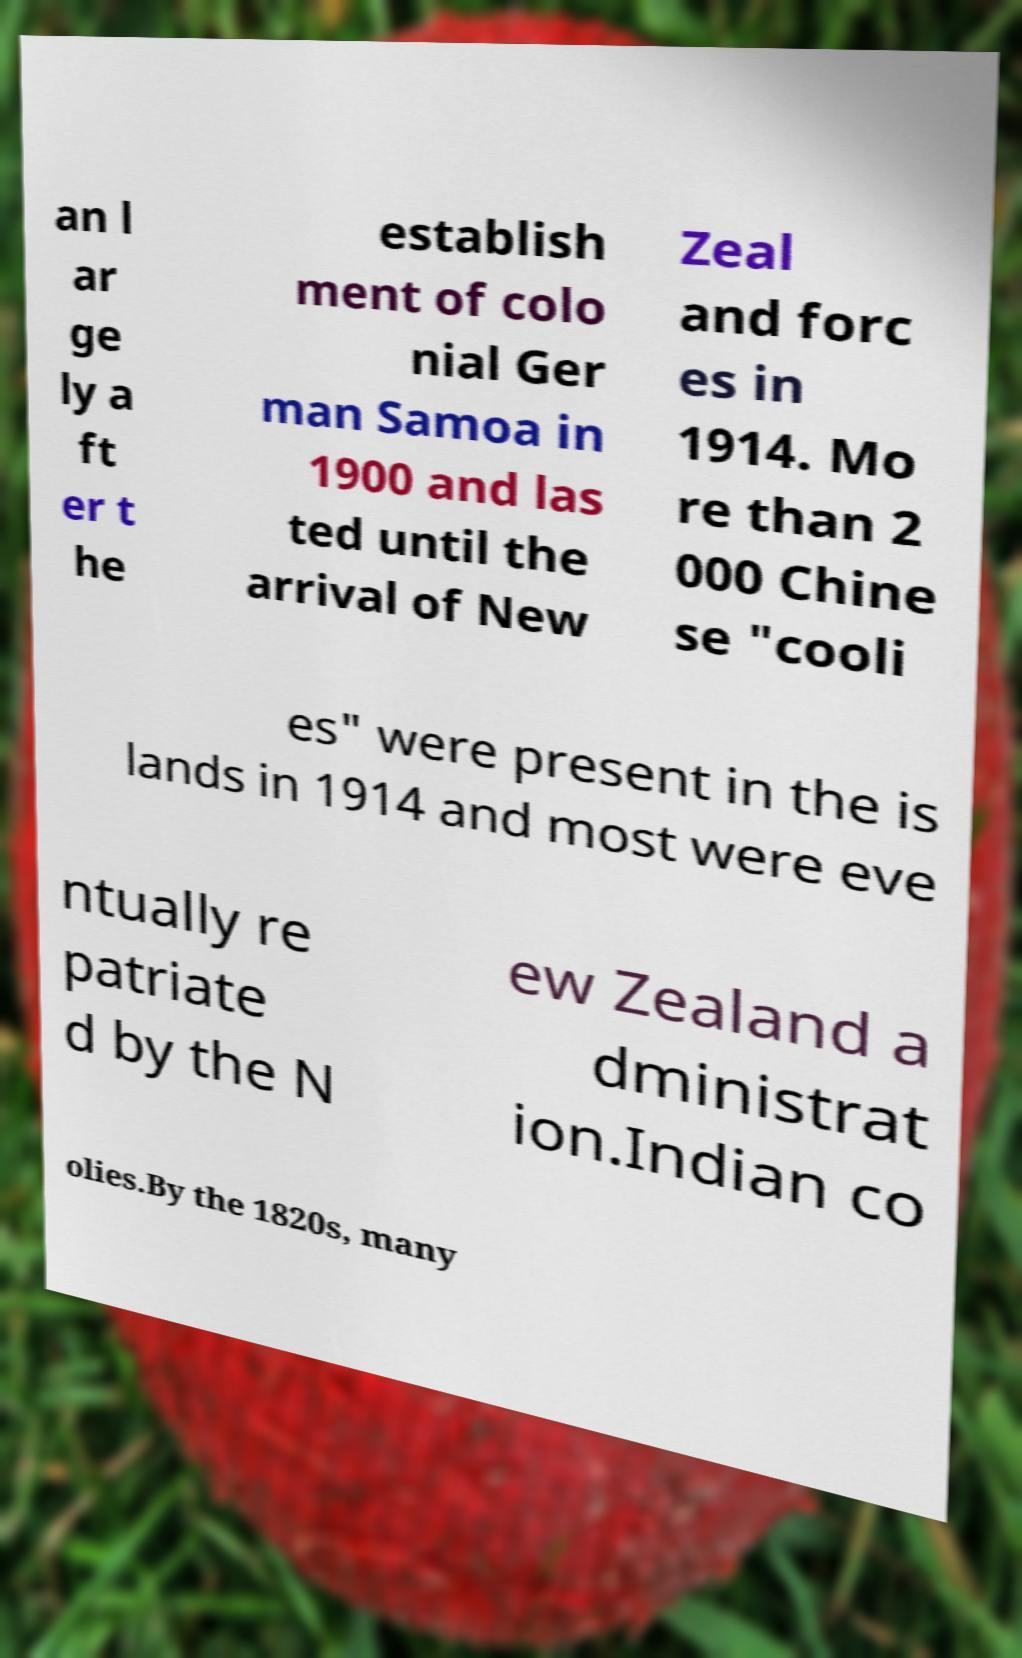Could you extract and type out the text from this image? an l ar ge ly a ft er t he establish ment of colo nial Ger man Samoa in 1900 and las ted until the arrival of New Zeal and forc es in 1914. Mo re than 2 000 Chine se "cooli es" were present in the is lands in 1914 and most were eve ntually re patriate d by the N ew Zealand a dministrat ion.Indian co olies.By the 1820s, many 